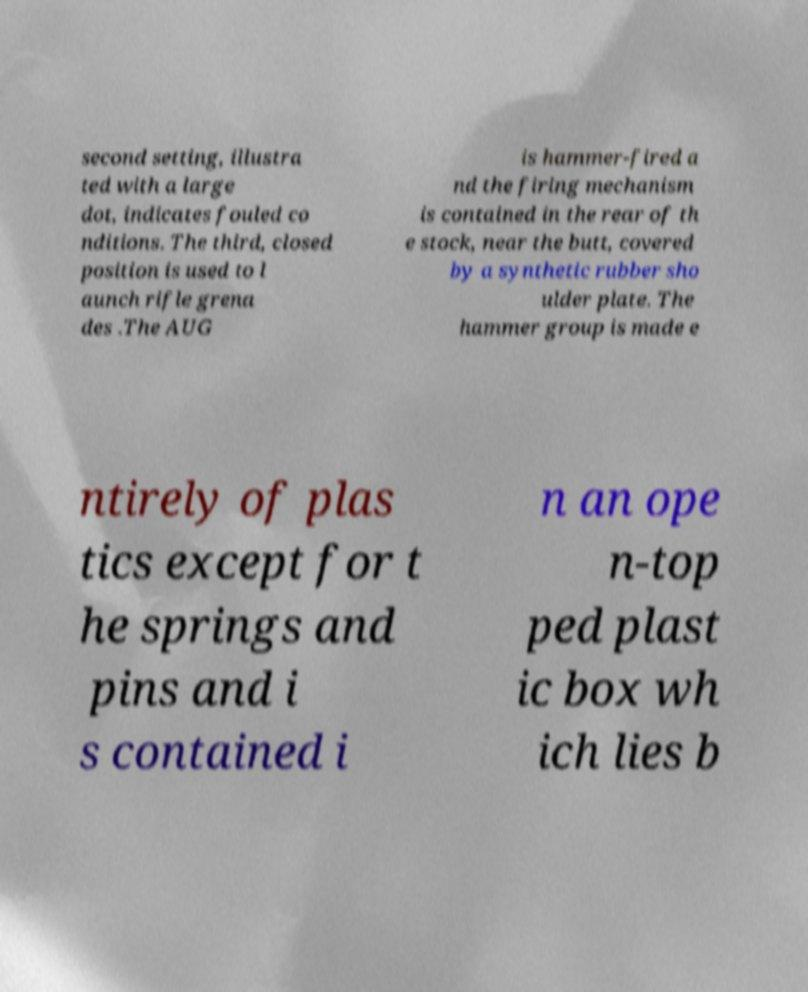Please identify and transcribe the text found in this image. second setting, illustra ted with a large dot, indicates fouled co nditions. The third, closed position is used to l aunch rifle grena des .The AUG is hammer-fired a nd the firing mechanism is contained in the rear of th e stock, near the butt, covered by a synthetic rubber sho ulder plate. The hammer group is made e ntirely of plas tics except for t he springs and pins and i s contained i n an ope n-top ped plast ic box wh ich lies b 